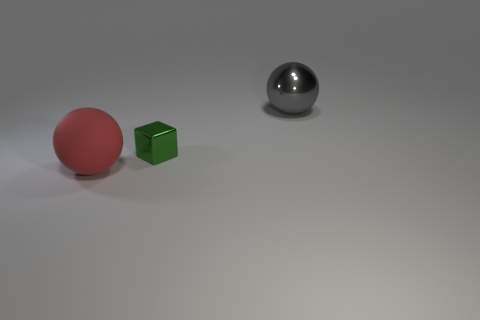Subtract all brown cubes. Subtract all purple spheres. How many cubes are left? 1 Add 2 green objects. How many objects exist? 5 Subtract all balls. How many objects are left? 1 Add 2 big spheres. How many big spheres are left? 4 Add 1 small objects. How many small objects exist? 2 Subtract 0 gray cylinders. How many objects are left? 3 Subtract all blue rubber cylinders. Subtract all small green things. How many objects are left? 2 